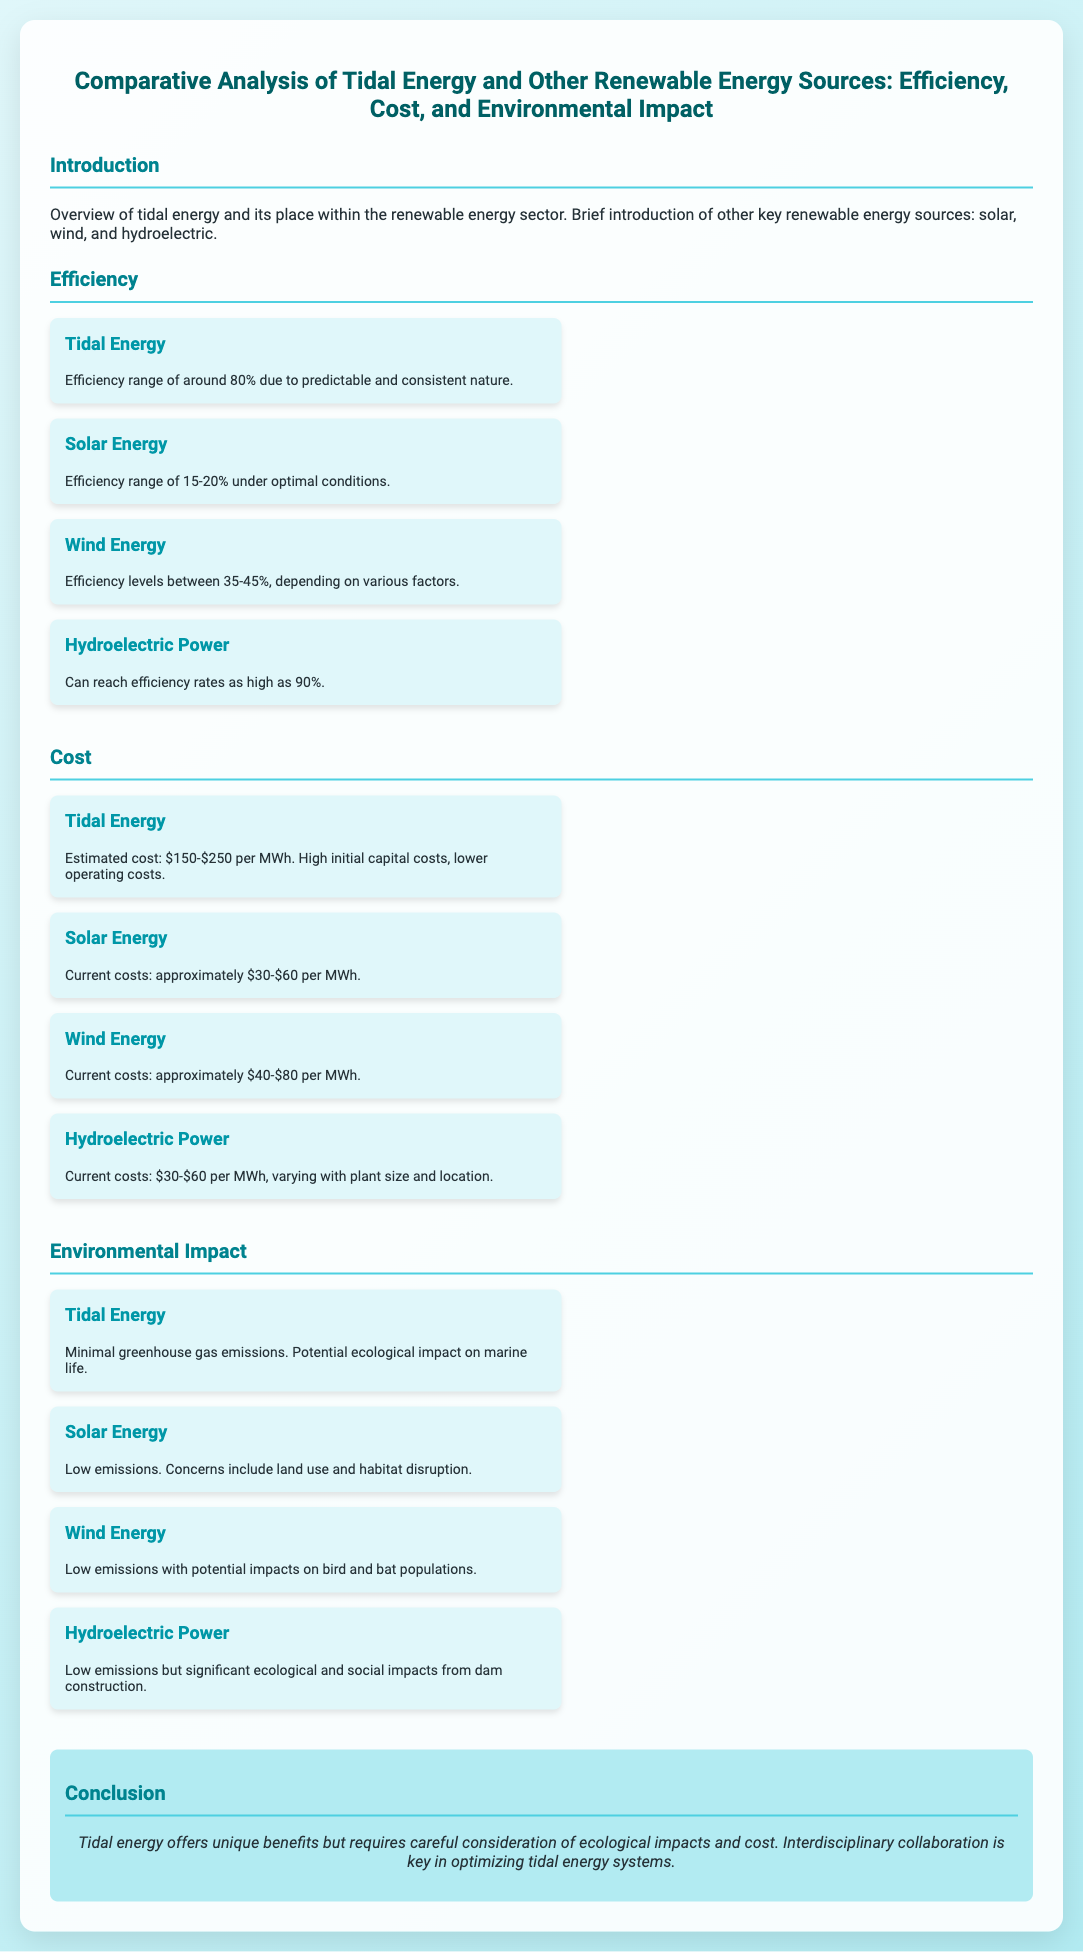what is the efficiency range of tidal energy? The efficiency range for tidal energy is approximately 80% according to the document.
Answer: 80% what is the cost range of tidal energy per MWh? The document states that the estimated cost for tidal energy is $150-$250 per MWh.
Answer: $150-$250 which renewable energy source has the highest efficiency? The efficiency rates can be as high as 90% for hydroelectric power, making it the highest among the listed sources.
Answer: Hydroelectric Power what are the potential ecological impacts associated with tidal energy? The document mentions potential ecological impact on marine life associated with tidal energy.
Answer: Marine life what is the estimated cost of solar energy per MWh? The current costs for solar energy are approximately $30-$60 per MWh, as stated in the document.
Answer: $30-$60 what is a key benefit of tidal energy mentioned in the conclusion? The conclusion highlights that tidal energy offers unique benefits, specifically in terms of predictable and consistent energy production.
Answer: Unique benefits which renewable energy source has land use concerns? The document discusses land use and habitat disruption concerns associated with solar energy.
Answer: Solar Energy what is the primary environmental concern for hydroelectric power? Significant ecological and social impacts result from dam construction, as noted in the document.
Answer: Dam construction 